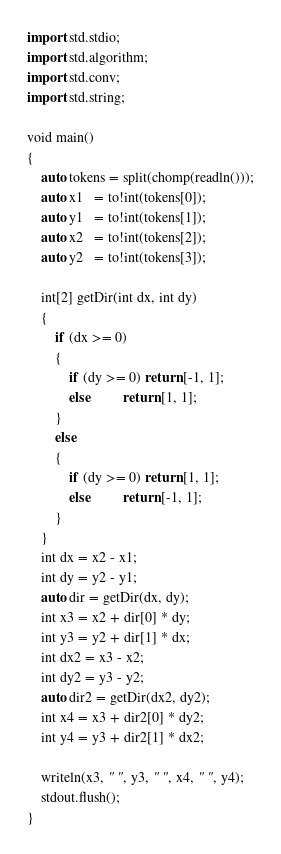Convert code to text. <code><loc_0><loc_0><loc_500><loc_500><_D_>import std.stdio;
import std.algorithm;
import std.conv;
import std.string;

void main()
{
	auto tokens = split(chomp(readln()));
	auto x1   = to!int(tokens[0]);
	auto y1   = to!int(tokens[1]);
	auto x2   = to!int(tokens[2]);
	auto y2   = to!int(tokens[3]);

	int[2] getDir(int dx, int dy)
	{
		if (dx >= 0)
		{
			if (dy >= 0) return [-1, 1];
			else		 return [1, 1];
		}
		else
		{
			if (dy >= 0) return [1, 1];
			else		 return [-1, 1];
		}
	}
	int dx = x2 - x1;
	int dy = y2 - y1;
	auto dir = getDir(dx, dy);
	int x3 = x2 + dir[0] * dy;
	int y3 = y2 + dir[1] * dx;
	int dx2 = x3 - x2;
	int dy2 = y3 - y2;
	auto dir2 = getDir(dx2, dy2);
	int x4 = x3 + dir2[0] * dy2;
	int y4 = y3 + dir2[1] * dx2;
	
	writeln(x3, " ", y3, " ", x4, " ", y4);
	stdout.flush();
}</code> 